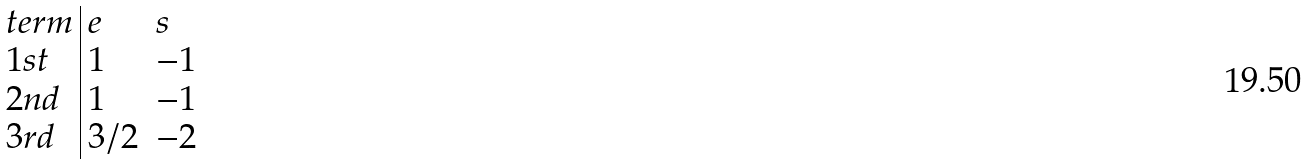<formula> <loc_0><loc_0><loc_500><loc_500>\begin{array} { l | l l } t e r m & e & s \\ 1 s t & 1 & - 1 \\ 2 n d & 1 & - 1 \\ 3 r d & 3 / 2 & - 2 \end{array}</formula> 